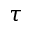Convert formula to latex. <formula><loc_0><loc_0><loc_500><loc_500>\tau</formula> 